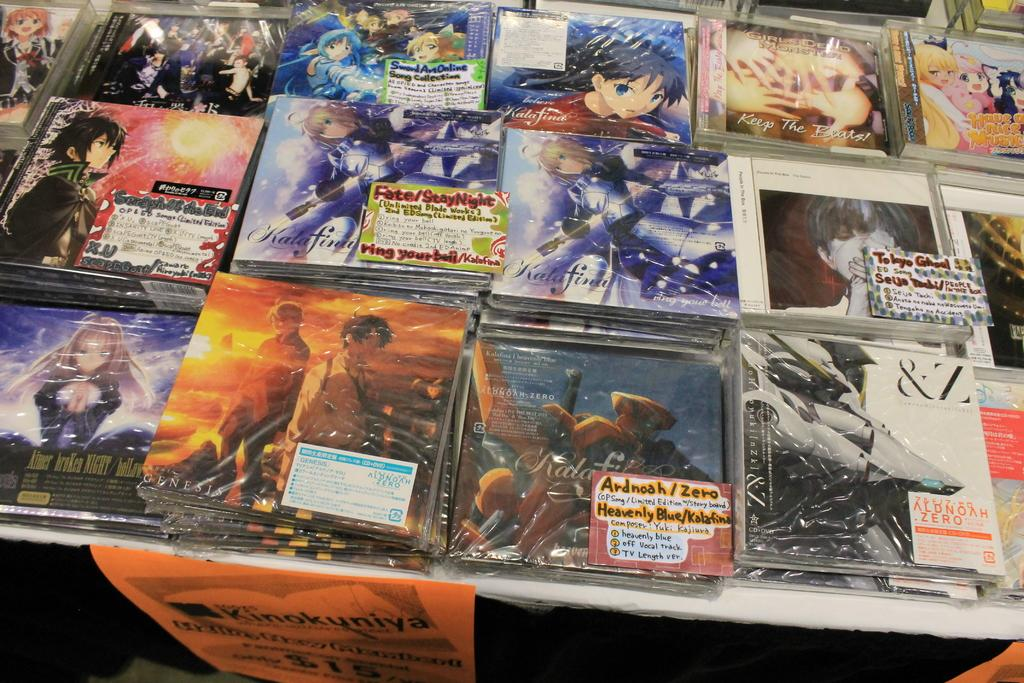<image>
Write a terse but informative summary of the picture. Many discs in covers shown on a table including Aldnoah Zero. 